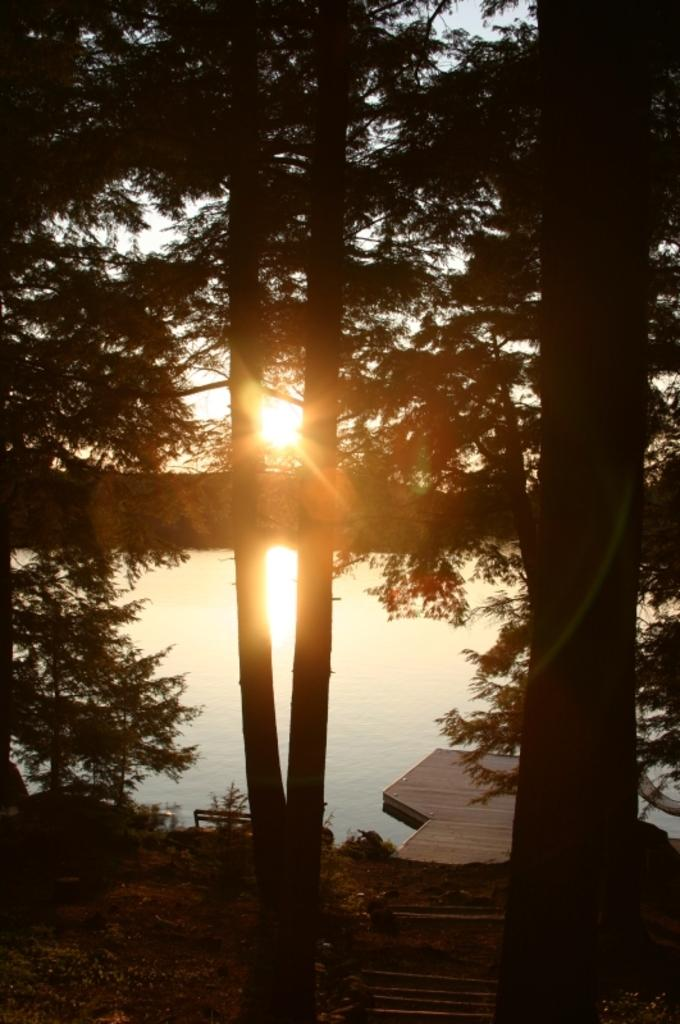What is floating on the water in the image? There is a wooden plank on the water in the image. What can be seen below the water in the image? The ground is visible in the image. What type of vegetation is present in the image? There are trees in the image. What is visible in the background of the image? The sky is visible in the background, and sunlight is present. What type of leaf is being used to gain approval from the beetle in the image? There is no beetle or leaf present in the image. 